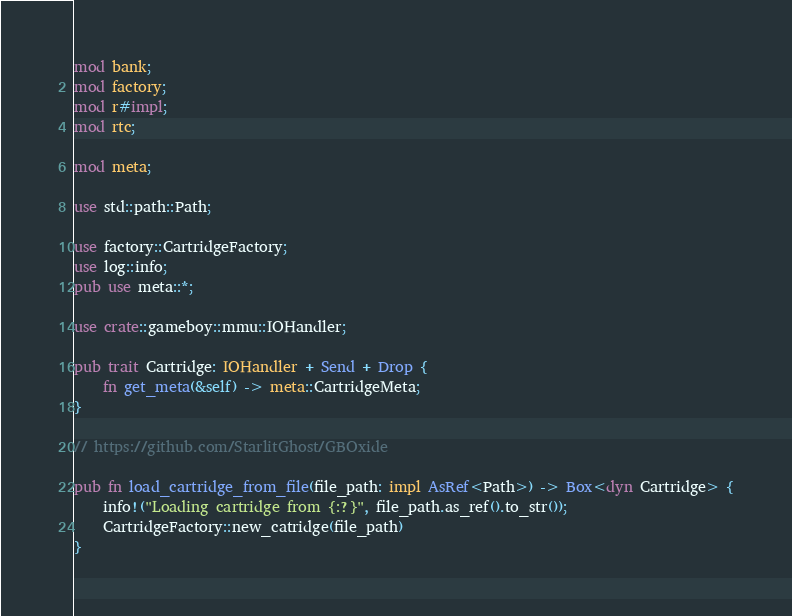<code> <loc_0><loc_0><loc_500><loc_500><_Rust_>mod bank;
mod factory;
mod r#impl;
mod rtc;

mod meta;

use std::path::Path;

use factory::CartridgeFactory;
use log::info;
pub use meta::*;

use crate::gameboy::mmu::IOHandler;

pub trait Cartridge: IOHandler + Send + Drop {
    fn get_meta(&self) -> meta::CartridgeMeta;
}

// https://github.com/StarlitGhost/GBOxide

pub fn load_cartridge_from_file(file_path: impl AsRef<Path>) -> Box<dyn Cartridge> {
    info!("Loading cartridge from {:?}", file_path.as_ref().to_str());
    CartridgeFactory::new_catridge(file_path)
}
</code> 